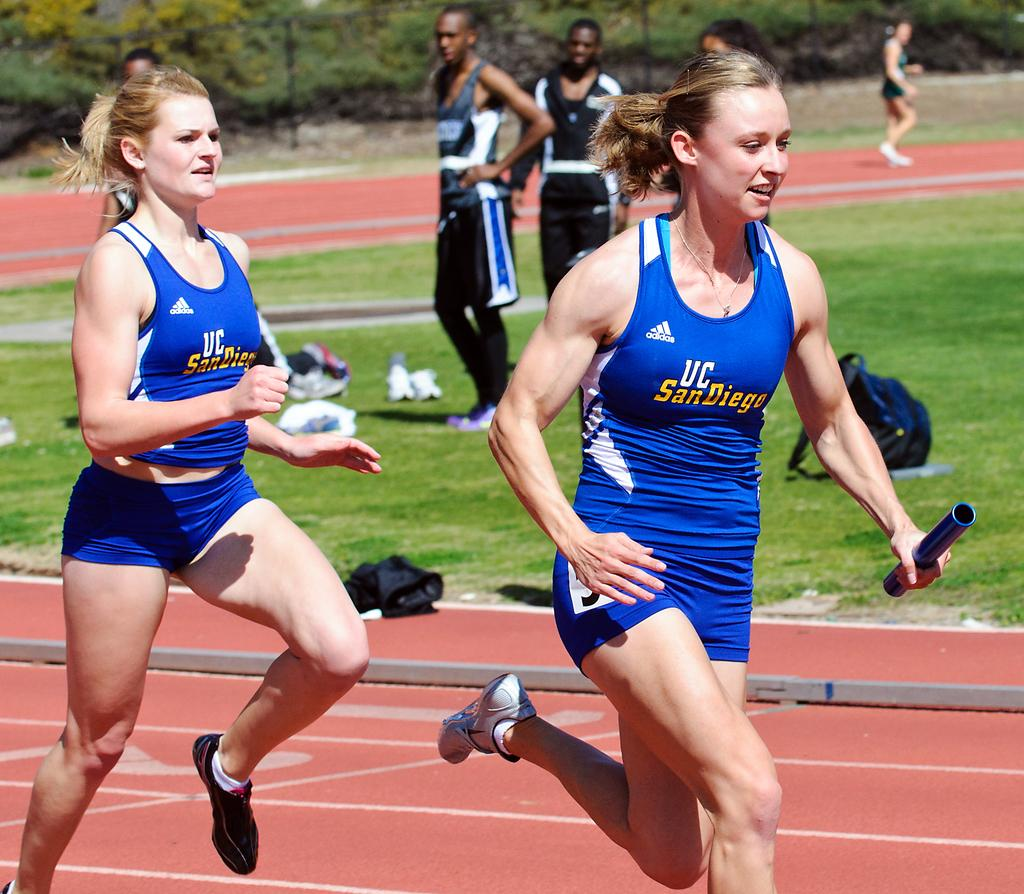<image>
Share a concise interpretation of the image provided. Women on the UC San Diego team run on the track. 